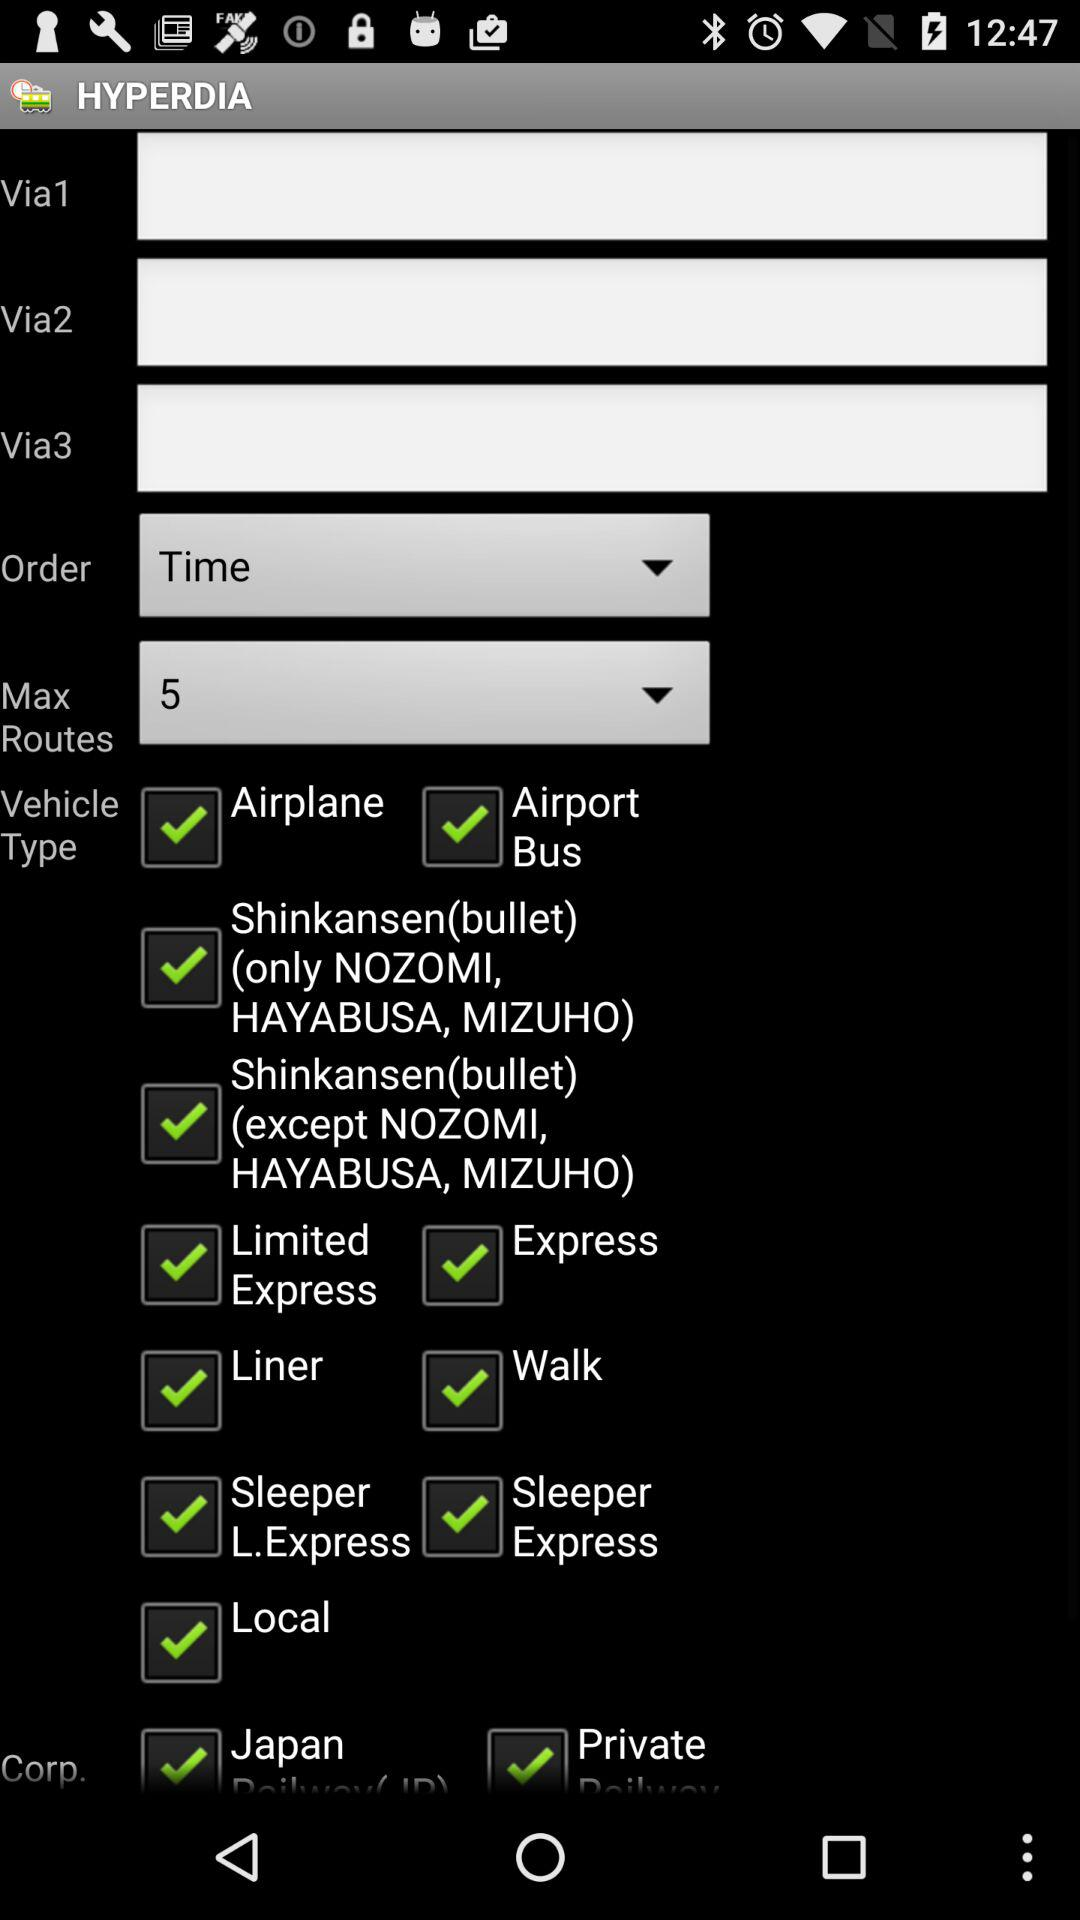How many checkboxes are there for Shinkansen(bullet) trains?
Answer the question using a single word or phrase. 2 